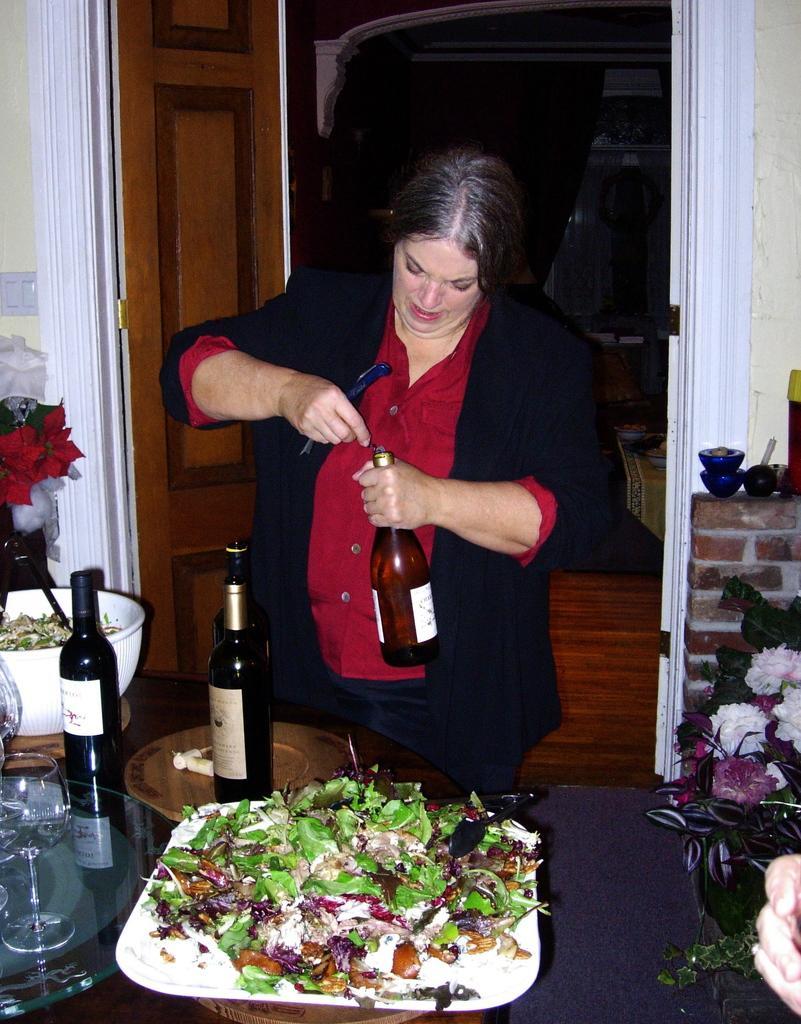Describe this image in one or two sentences. In this image I can see a woman wearing maroon dress and black jacket is standing and holding a bottle and few other object in he hands. In front of her I can see a table and on the table I can see a plate, few food items in the plate, few bottles, a bowl and few other objects. In the background I can see a brown colored door, a white colored wall and few other objects. 